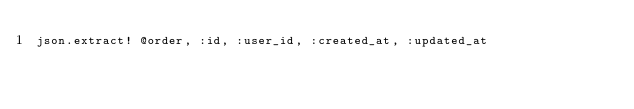<code> <loc_0><loc_0><loc_500><loc_500><_Ruby_>json.extract! @order, :id, :user_id, :created_at, :updated_at
</code> 